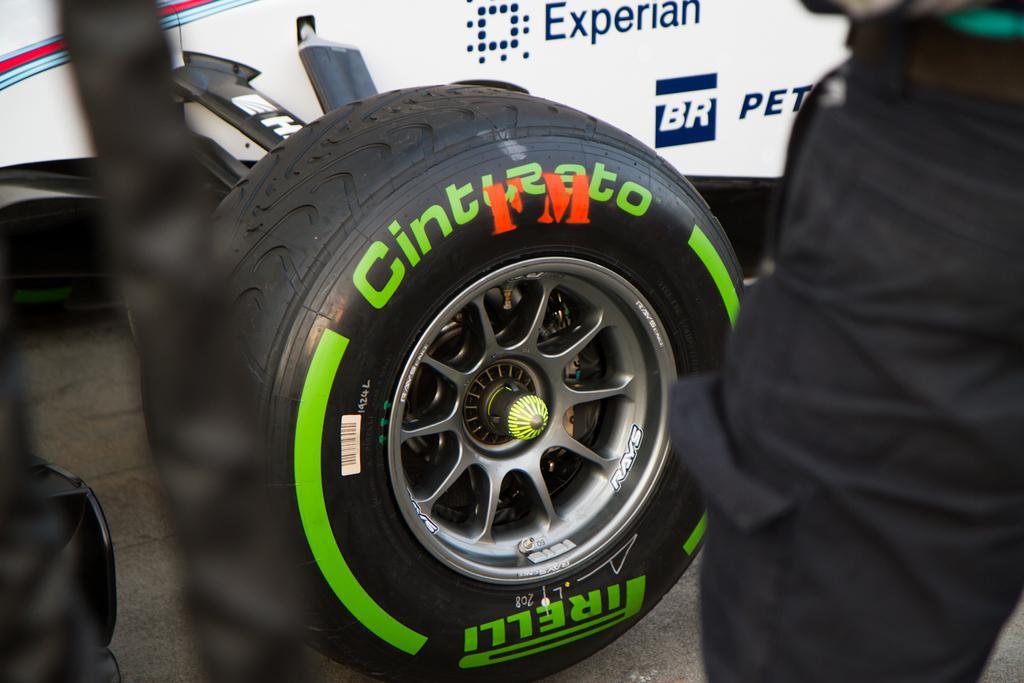Can you describe this image briefly? In this image we can see the wheel of a heavy vehicle. Here we can see a person on the right side, though his face is not visible. 